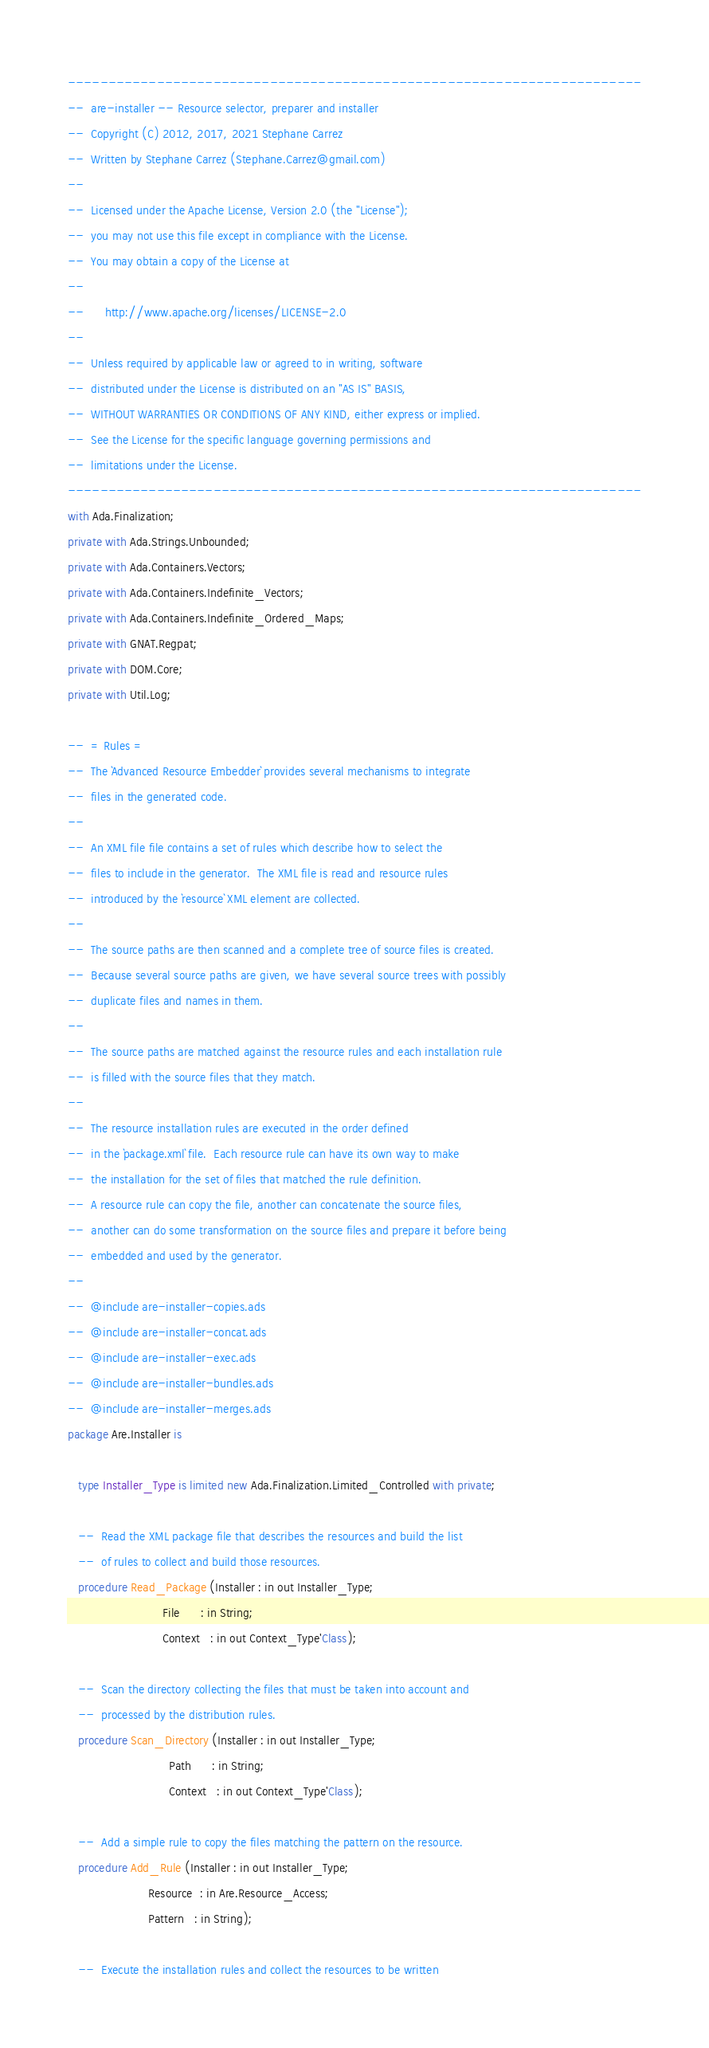<code> <loc_0><loc_0><loc_500><loc_500><_Ada_>-----------------------------------------------------------------------
--  are-installer -- Resource selector, preparer and installer
--  Copyright (C) 2012, 2017, 2021 Stephane Carrez
--  Written by Stephane Carrez (Stephane.Carrez@gmail.com)
--
--  Licensed under the Apache License, Version 2.0 (the "License");
--  you may not use this file except in compliance with the License.
--  You may obtain a copy of the License at
--
--      http://www.apache.org/licenses/LICENSE-2.0
--
--  Unless required by applicable law or agreed to in writing, software
--  distributed under the License is distributed on an "AS IS" BASIS,
--  WITHOUT WARRANTIES OR CONDITIONS OF ANY KIND, either express or implied.
--  See the License for the specific language governing permissions and
--  limitations under the License.
-----------------------------------------------------------------------
with Ada.Finalization;
private with Ada.Strings.Unbounded;
private with Ada.Containers.Vectors;
private with Ada.Containers.Indefinite_Vectors;
private with Ada.Containers.Indefinite_Ordered_Maps;
private with GNAT.Regpat;
private with DOM.Core;
private with Util.Log;

--  = Rules =
--  The `Advanced Resource Embedder` provides several mechanisms to integrate
--  files in the generated code.
--
--  An XML file file contains a set of rules which describe how to select the
--  files to include in the generator.  The XML file is read and resource rules
--  introduced by the `resource` XML element are collected.
--
--  The source paths are then scanned and a complete tree of source files is created.
--  Because several source paths are given, we have several source trees with possibly
--  duplicate files and names in them.
--
--  The source paths are matched against the resource rules and each installation rule
--  is filled with the source files that they match.
--
--  The resource installation rules are executed in the order defined
--  in the `package.xml` file.  Each resource rule can have its own way to make
--  the installation for the set of files that matched the rule definition.
--  A resource rule can copy the file, another can concatenate the source files,
--  another can do some transformation on the source files and prepare it before being
--  embedded and used by the generator.
--
--  @include are-installer-copies.ads
--  @include are-installer-concat.ads
--  @include are-installer-exec.ads
--  @include are-installer-bundles.ads
--  @include are-installer-merges.ads
package Are.Installer is

   type Installer_Type is limited new Ada.Finalization.Limited_Controlled with private;

   --  Read the XML package file that describes the resources and build the list
   --  of rules to collect and build those resources.
   procedure Read_Package (Installer : in out Installer_Type;
                           File      : in String;
                           Context   : in out Context_Type'Class);

   --  Scan the directory collecting the files that must be taken into account and
   --  processed by the distribution rules.
   procedure Scan_Directory (Installer : in out Installer_Type;
                             Path      : in String;
                             Context   : in out Context_Type'Class);

   --  Add a simple rule to copy the files matching the pattern on the resource.
   procedure Add_Rule (Installer : in out Installer_Type;
                       Resource  : in Are.Resource_Access;
                       Pattern   : in String);

   --  Execute the installation rules and collect the resources to be written</code> 